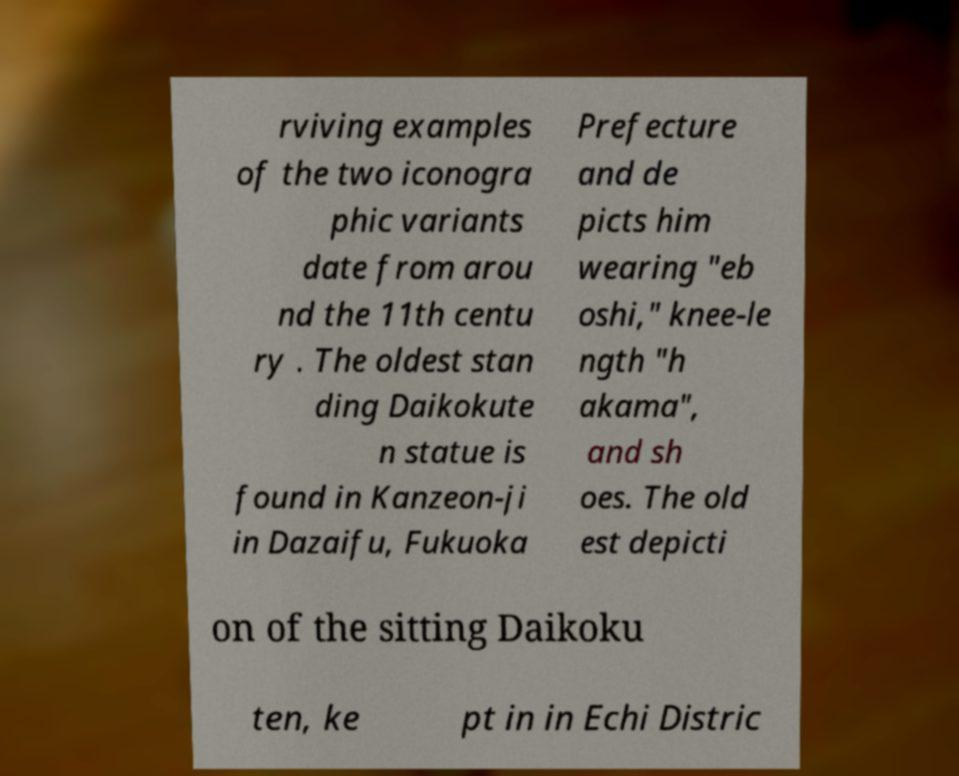Could you assist in decoding the text presented in this image and type it out clearly? rviving examples of the two iconogra phic variants date from arou nd the 11th centu ry . The oldest stan ding Daikokute n statue is found in Kanzeon-ji in Dazaifu, Fukuoka Prefecture and de picts him wearing "eb oshi," knee-le ngth "h akama", and sh oes. The old est depicti on of the sitting Daikoku ten, ke pt in in Echi Distric 